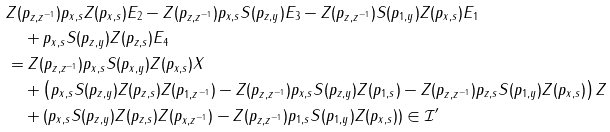<formula> <loc_0><loc_0><loc_500><loc_500>& Z ( p _ { z , z ^ { - 1 } } ) p _ { x , s } Z ( p _ { x , s } ) E _ { 2 } - Z ( p _ { z , z ^ { - 1 } } ) p _ { x , s } S ( p _ { z , y } ) E _ { 3 } - Z ( p _ { z , z ^ { - 1 } } ) S ( p _ { 1 , y } ) Z ( p _ { x , s } ) E _ { 1 } \\ & \quad + p _ { x , s } S ( p _ { z , y } ) Z ( p _ { z , s } ) E _ { 4 } \\ & = Z ( p _ { z , z ^ { - 1 } } ) p _ { x , s } S ( p _ { x , y } ) Z ( p _ { x , s } ) X \\ & \quad + \left ( p _ { x , s } S ( p _ { z , y } ) Z ( p _ { z , s } ) Z ( p _ { 1 , z ^ { - 1 } } ) - Z ( p _ { z , z ^ { - 1 } } ) p _ { x , s } S ( p _ { z , y } ) Z ( p _ { 1 , s } ) - Z ( p _ { z , z ^ { - 1 } } ) p _ { z , s } S ( p _ { 1 , y } ) Z ( p _ { x , s } ) \right ) Z \\ & \quad + ( p _ { x , s } S ( p _ { z , y } ) Z ( p _ { z , s } ) Z ( p _ { x , z ^ { - 1 } } ) - Z ( p _ { z , z ^ { - 1 } } ) p _ { 1 , s } S ( p _ { 1 , y } ) Z ( p _ { x , s } ) ) \in \mathcal { I } ^ { \prime }</formula> 